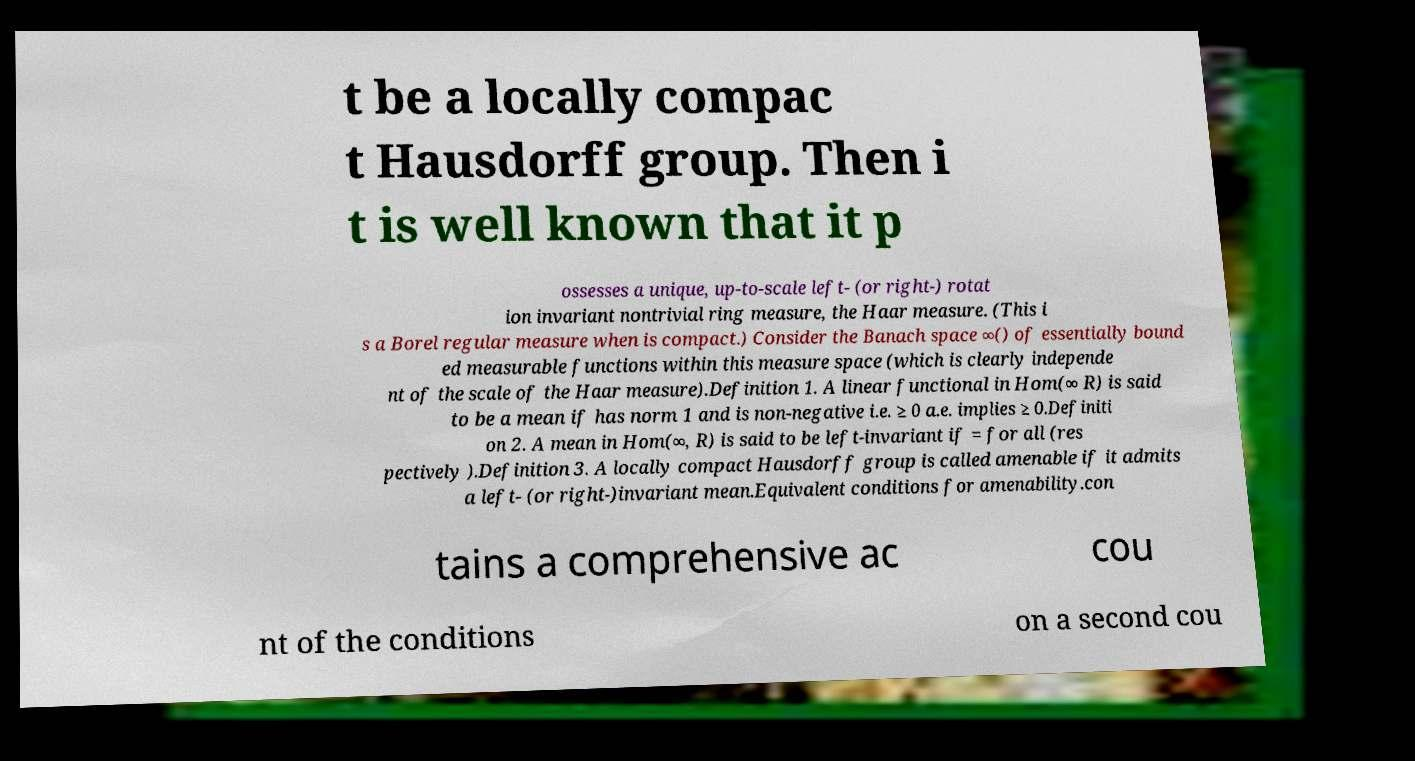There's text embedded in this image that I need extracted. Can you transcribe it verbatim? t be a locally compac t Hausdorff group. Then i t is well known that it p ossesses a unique, up-to-scale left- (or right-) rotat ion invariant nontrivial ring measure, the Haar measure. (This i s a Borel regular measure when is compact.) Consider the Banach space ∞() of essentially bound ed measurable functions within this measure space (which is clearly independe nt of the scale of the Haar measure).Definition 1. A linear functional in Hom(∞ R) is said to be a mean if has norm 1 and is non-negative i.e. ≥ 0 a.e. implies ≥ 0.Definiti on 2. A mean in Hom(∞, R) is said to be left-invariant if = for all (res pectively ).Definition 3. A locally compact Hausdorff group is called amenable if it admits a left- (or right-)invariant mean.Equivalent conditions for amenability.con tains a comprehensive ac cou nt of the conditions on a second cou 